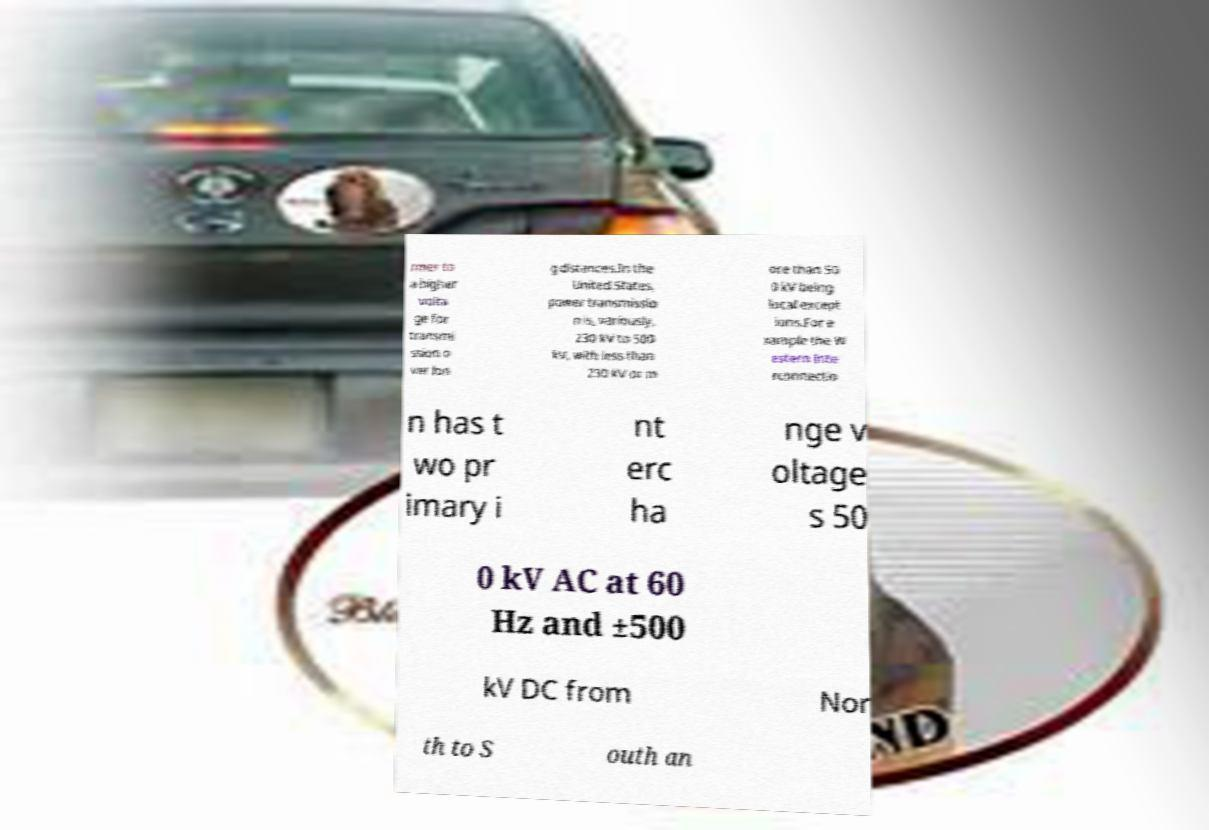For documentation purposes, I need the text within this image transcribed. Could you provide that? rmer to a higher volta ge for transmi ssion o ver lon g distances.In the United States, power transmissio n is, variously, 230 kV to 500 kV, with less than 230 kV or m ore than 50 0 kV being local except ions.For e xample the W estern Inte rconnectio n has t wo pr imary i nt erc ha nge v oltage s 50 0 kV AC at 60 Hz and ±500 kV DC from Nor th to S outh an 